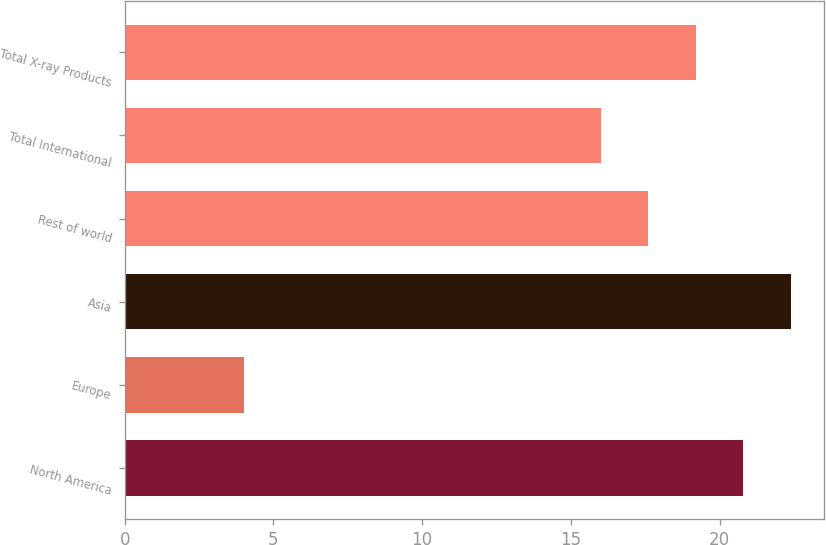Convert chart. <chart><loc_0><loc_0><loc_500><loc_500><bar_chart><fcel>North America<fcel>Europe<fcel>Asia<fcel>Rest of world<fcel>Total International<fcel>Total X-ray Products<nl><fcel>20.8<fcel>4<fcel>22.4<fcel>17.6<fcel>16<fcel>19.2<nl></chart> 